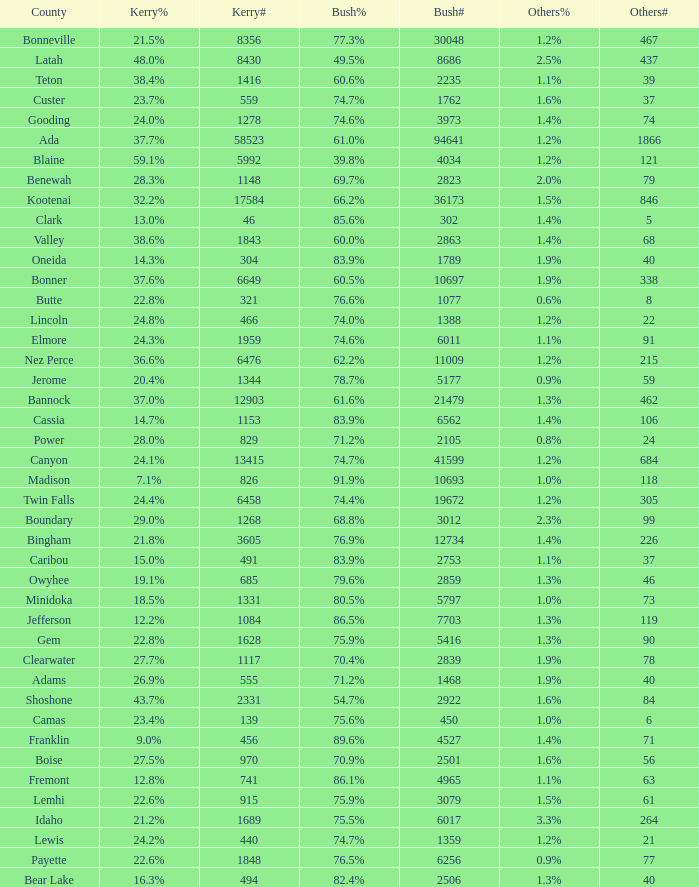How many people voted for Kerry in the county where 8 voted for others? 321.0. 